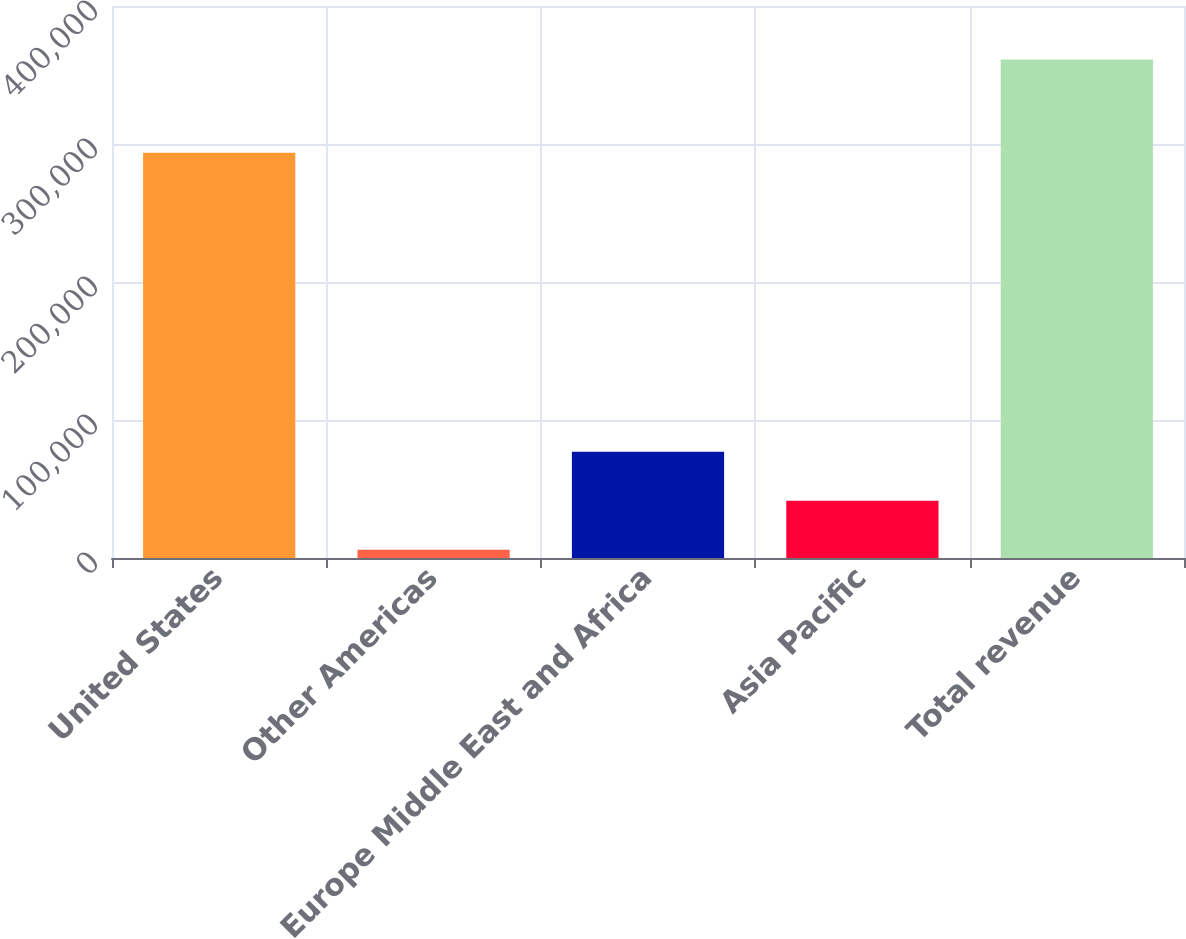Convert chart to OTSL. <chart><loc_0><loc_0><loc_500><loc_500><bar_chart><fcel>United States<fcel>Other Americas<fcel>Europe Middle East and Africa<fcel>Asia Pacific<fcel>Total revenue<nl><fcel>293579<fcel>6040<fcel>77076.8<fcel>41558.4<fcel>361224<nl></chart> 